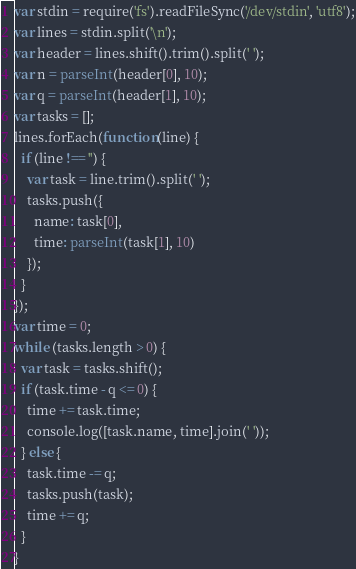<code> <loc_0><loc_0><loc_500><loc_500><_JavaScript_>var stdin = require('fs').readFileSync('/dev/stdin', 'utf8');
var lines = stdin.split('\n');
var header = lines.shift().trim().split(' ');
var n = parseInt(header[0], 10);
var q = parseInt(header[1], 10);
var tasks = [];
lines.forEach(function(line) {
  if (line !== '') {
    var task = line.trim().split(' ');
    tasks.push({
      name: task[0],
      time: parseInt(task[1], 10)
    });
  }
});
var time = 0;
while (tasks.length > 0) {
  var task = tasks.shift();
  if (task.time - q <= 0) {
    time += task.time;
    console.log([task.name, time].join(' '));
  } else {
    task.time -= q;
    tasks.push(task);
    time += q;
  }
}</code> 